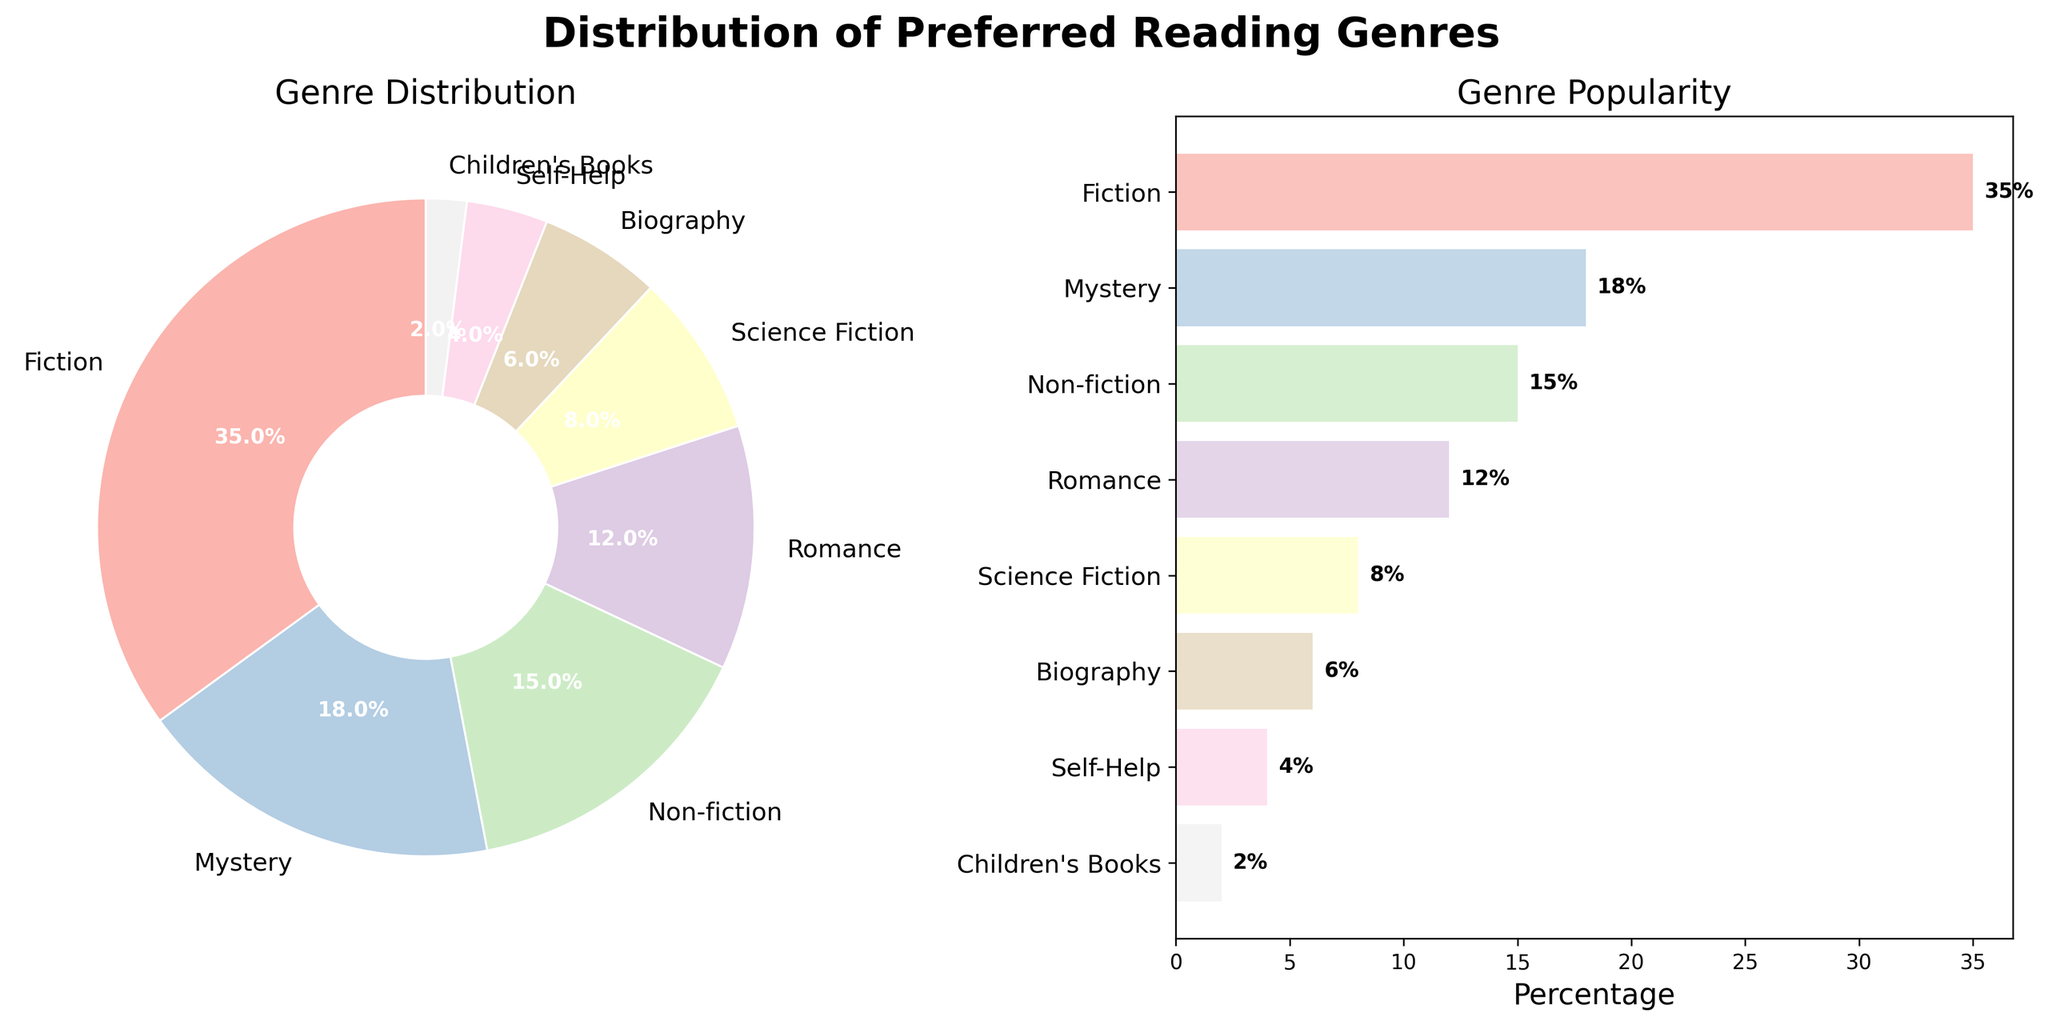what's the highest percentage genre among library patrons? By looking at the pie chart and the bar chart, we can see which genre has the largest wedge in the pie chart and the longest bar in the bar chart. Both indicate that Fiction has the highest percentage, labeled at 35%
Answer: Fiction which genre has the smallest preference percentage? From both the pie chart and the horizontal bar chart, the smallest wedge and the shortest bar are labeled with Children's Books, indicating it has the lowest percentage of 2%
Answer: Children's Books how many genres are represented in the figure? By counting the number of wedges in the pie chart or the number of bars in the bar chart, we can see there are 8 genres represented
Answer: 8 compare the popularity of Romance and Biography genres. Which one is more preferred? By observing the lengths of the bars in the bar chart and the corresponding wedges in the pie chart, Romance has a percentage of 12% while Biography has 6%. Therefore, Romance is more preferred than Biography
Answer: Romance what's the combined percentage of Fiction and Non-fiction genres? Adding the percentages of Fiction and Non-fiction from the figure: 35% (Fiction) + 15% (Non-fiction) = 50%
Answer: 50% are there any genres with a percentage exactly equal to 10%? By reviewing all the labeled percentages in both the pie and bar charts, none of the genres show an exact 10% preference
Answer: No how much more preferred is Mystery than Science Fiction? Comparing the percentages of Mystery (18%) and Science Fiction (8%) and finding the difference: 18% - 8% = 10%
Answer: 10% which genre has the closest percentage preference to Self-Help? By comparing the percentages, Self-Help has 4%. The closest percentage to this is Children’s Books with 2%, but Self-Help itself is unique without close competitors
Answer: Children's Books what’s the total percentage of genres preferred by at least 10% of patrons? Summing the percentages of genres with at least 10% indicated preference: Fiction (35%) + Mystery (18%) + Non-fiction (15%) + Romance (12%) = 80%
Answer: 80% describe the common trend observed among the least preferred genres. By looking at the percentages for the bottom four genres (Science Fiction, Biography, Self-Help, Children's Books), it's evident that they all have single-digit percentages, indicating they are significantly less preferred than top genres
Answer: Single-digit percentages 